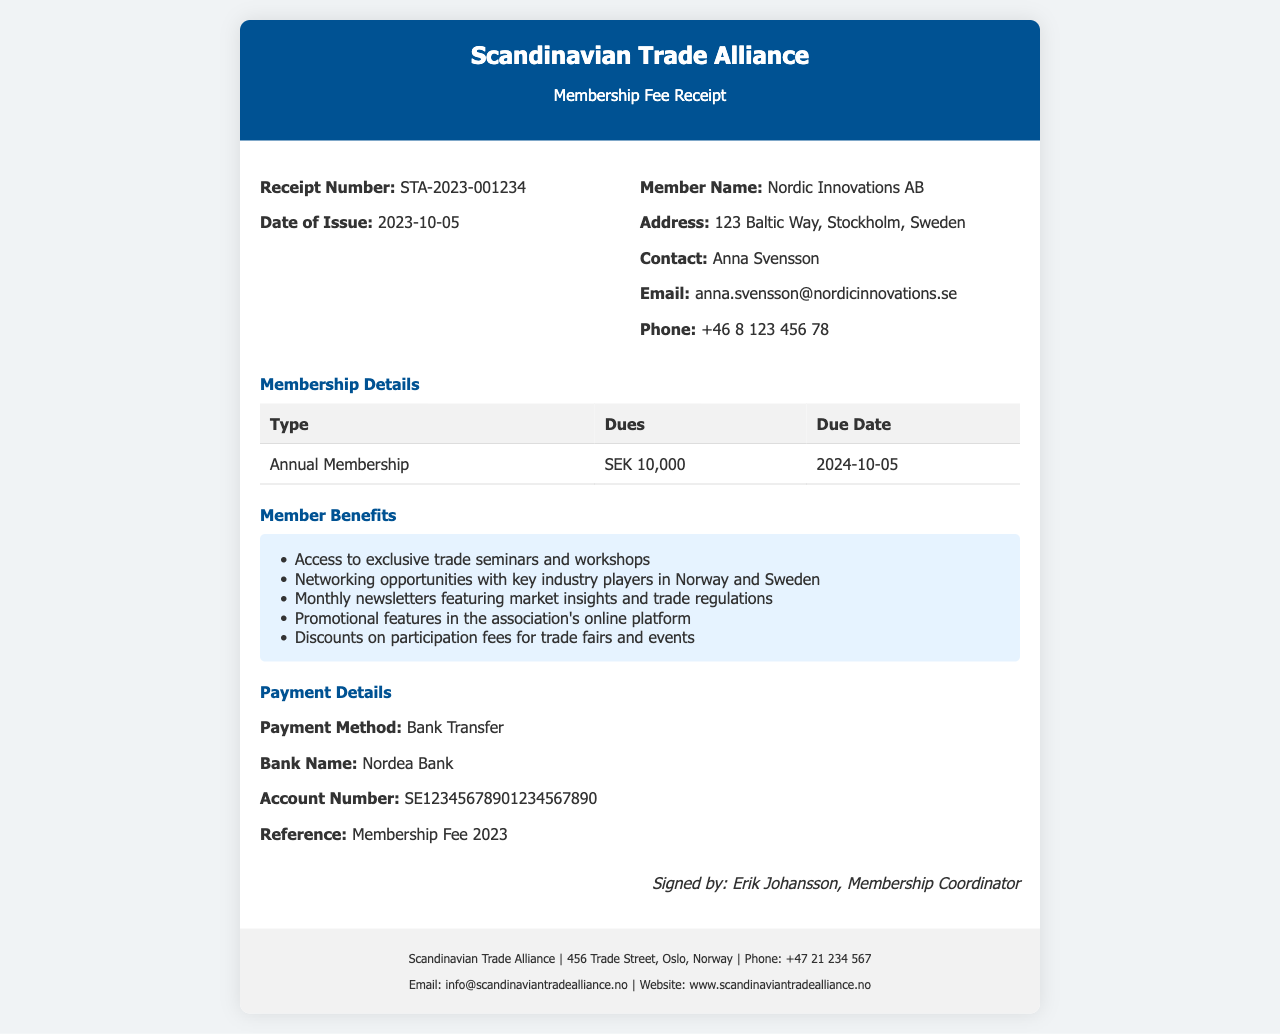What is the receipt number? The receipt number is a unique identifier for the transaction listed in the document.
Answer: STA-2023-001234 What is the membership dues amount? The dues amount is specified for the type of membership in the document.
Answer: SEK 10,000 Who is the contact person for the member? The contact person's name is included in the member details section of the document.
Answer: Anna Svensson When is the membership due date? The due date is mentioned in the membership details section and indicates when payment should be made.
Answer: 2024-10-05 What are the member benefits? Member benefits consist of various services offered to enhance member experience as listed in the document.
Answer: Access to exclusive trade seminars and workshops, Networking opportunities with key industry players in Norway and Sweden, Monthly newsletters featuring market insights and trade regulations, Promotional features in the association's online platform, Discounts on participation fees for trade fairs and events What payment method was used? The payment method section specifies how the membership fee was paid.
Answer: Bank Transfer Who signed the receipt? The document includes a signature from a representative indicating the authenticity of the receipt.
Answer: Erik Johansson What is the email address for the Scandinavian Trade Alliance? The email address is provided in the footer of the document.
Answer: info@scandinaviantradealliance.no What is the address of Nordic Innovations AB? The address is listed under the member details section in the document.
Answer: 123 Baltic Way, Stockholm, Sweden 